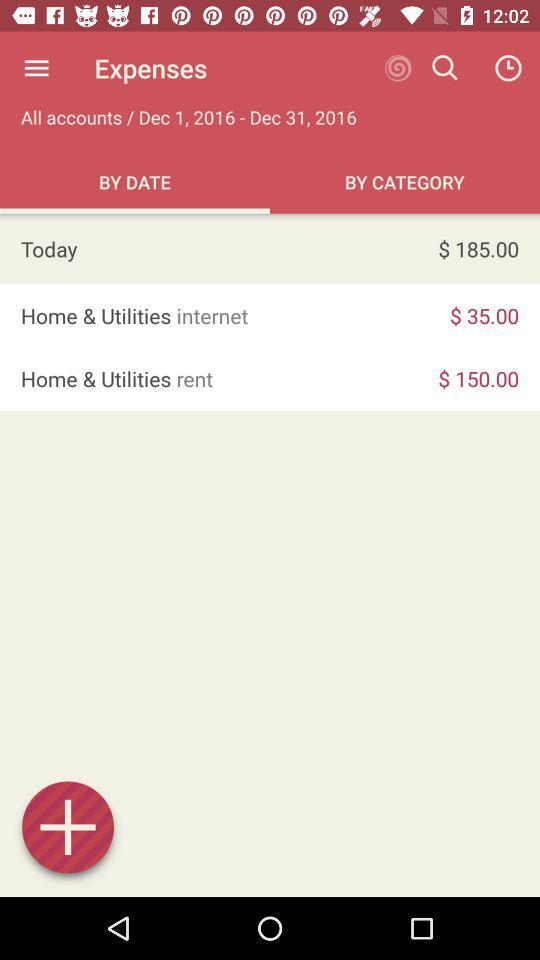How much more did I spend on rent than internet?
Answer the question using a single word or phrase. $115.00 